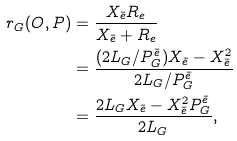<formula> <loc_0><loc_0><loc_500><loc_500>r _ { G } ( O , P ) & = \frac { X _ { \bar { e } } R _ { e } } { X _ { \bar { e } } + R _ { e } } \\ & = \frac { ( 2 L _ { G } / P ^ { \bar { e } } _ { G } ) X _ { \bar { e } } - X _ { \bar { e } } ^ { 2 } } { 2 L _ { G } / P ^ { \bar { e } } _ { G } } \\ & = \frac { 2 L _ { G } X _ { \bar { e } } - X _ { \bar { e } } ^ { 2 } P ^ { \bar { e } } _ { G } } { 2 L _ { G } } ,</formula> 